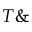<formula> <loc_0><loc_0><loc_500><loc_500>T \&</formula> 